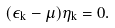<formula> <loc_0><loc_0><loc_500><loc_500>( \epsilon _ { k } - \mu ) \eta _ { k } = 0 .</formula> 